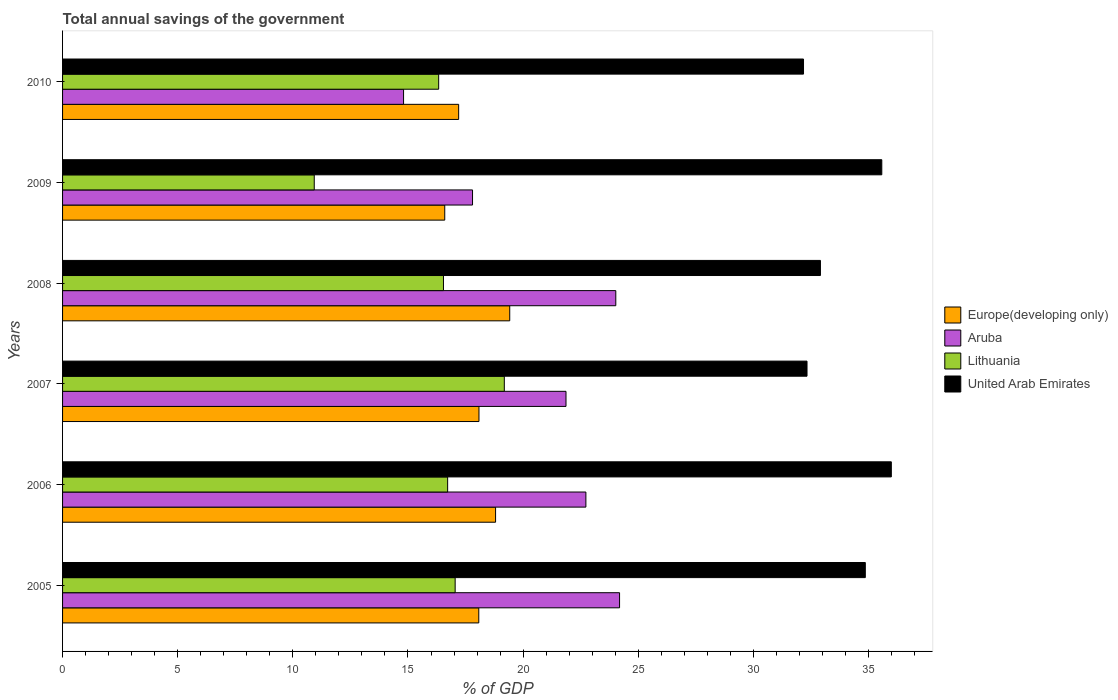How many bars are there on the 2nd tick from the top?
Give a very brief answer. 4. How many bars are there on the 6th tick from the bottom?
Offer a terse response. 4. What is the label of the 1st group of bars from the top?
Your response must be concise. 2010. What is the total annual savings of the government in Europe(developing only) in 2006?
Your response must be concise. 18.8. Across all years, what is the maximum total annual savings of the government in Europe(developing only)?
Give a very brief answer. 19.42. Across all years, what is the minimum total annual savings of the government in Aruba?
Give a very brief answer. 14.81. In which year was the total annual savings of the government in Aruba maximum?
Give a very brief answer. 2005. What is the total total annual savings of the government in Europe(developing only) in the graph?
Make the answer very short. 108.18. What is the difference between the total annual savings of the government in Europe(developing only) in 2005 and that in 2008?
Make the answer very short. -1.34. What is the difference between the total annual savings of the government in Lithuania in 2010 and the total annual savings of the government in United Arab Emirates in 2005?
Provide a succinct answer. -18.53. What is the average total annual savings of the government in Europe(developing only) per year?
Offer a terse response. 18.03. In the year 2009, what is the difference between the total annual savings of the government in United Arab Emirates and total annual savings of the government in Europe(developing only)?
Offer a very short reply. 18.98. What is the ratio of the total annual savings of the government in Europe(developing only) in 2005 to that in 2010?
Your answer should be very brief. 1.05. What is the difference between the highest and the second highest total annual savings of the government in Lithuania?
Keep it short and to the point. 2.14. What is the difference between the highest and the lowest total annual savings of the government in Aruba?
Make the answer very short. 9.38. In how many years, is the total annual savings of the government in United Arab Emirates greater than the average total annual savings of the government in United Arab Emirates taken over all years?
Provide a short and direct response. 3. Is it the case that in every year, the sum of the total annual savings of the government in United Arab Emirates and total annual savings of the government in Aruba is greater than the sum of total annual savings of the government in Lithuania and total annual savings of the government in Europe(developing only)?
Your answer should be compact. Yes. What does the 1st bar from the top in 2010 represents?
Offer a terse response. United Arab Emirates. What does the 4th bar from the bottom in 2007 represents?
Your answer should be very brief. United Arab Emirates. Is it the case that in every year, the sum of the total annual savings of the government in Europe(developing only) and total annual savings of the government in United Arab Emirates is greater than the total annual savings of the government in Aruba?
Provide a succinct answer. Yes. Are all the bars in the graph horizontal?
Provide a succinct answer. Yes. Does the graph contain any zero values?
Your response must be concise. No. Does the graph contain grids?
Give a very brief answer. No. What is the title of the graph?
Ensure brevity in your answer.  Total annual savings of the government. Does "Tonga" appear as one of the legend labels in the graph?
Ensure brevity in your answer.  No. What is the label or title of the X-axis?
Offer a very short reply. % of GDP. What is the label or title of the Y-axis?
Provide a short and direct response. Years. What is the % of GDP in Europe(developing only) in 2005?
Make the answer very short. 18.07. What is the % of GDP in Aruba in 2005?
Offer a very short reply. 24.19. What is the % of GDP in Lithuania in 2005?
Make the answer very short. 17.05. What is the % of GDP in United Arab Emirates in 2005?
Your response must be concise. 34.86. What is the % of GDP of Europe(developing only) in 2006?
Make the answer very short. 18.8. What is the % of GDP in Aruba in 2006?
Provide a short and direct response. 22.73. What is the % of GDP in Lithuania in 2006?
Ensure brevity in your answer.  16.72. What is the % of GDP of United Arab Emirates in 2006?
Your answer should be compact. 35.99. What is the % of GDP in Europe(developing only) in 2007?
Make the answer very short. 18.08. What is the % of GDP in Aruba in 2007?
Offer a terse response. 21.86. What is the % of GDP of Lithuania in 2007?
Make the answer very short. 19.18. What is the % of GDP in United Arab Emirates in 2007?
Offer a very short reply. 32.33. What is the % of GDP in Europe(developing only) in 2008?
Provide a short and direct response. 19.42. What is the % of GDP in Aruba in 2008?
Make the answer very short. 24.02. What is the % of GDP of Lithuania in 2008?
Offer a terse response. 16.54. What is the % of GDP in United Arab Emirates in 2008?
Give a very brief answer. 32.91. What is the % of GDP in Europe(developing only) in 2009?
Your response must be concise. 16.6. What is the % of GDP in Aruba in 2009?
Offer a very short reply. 17.8. What is the % of GDP of Lithuania in 2009?
Ensure brevity in your answer.  10.93. What is the % of GDP of United Arab Emirates in 2009?
Offer a terse response. 35.58. What is the % of GDP of Europe(developing only) in 2010?
Your answer should be compact. 17.2. What is the % of GDP in Aruba in 2010?
Your answer should be compact. 14.81. What is the % of GDP of Lithuania in 2010?
Provide a succinct answer. 16.33. What is the % of GDP of United Arab Emirates in 2010?
Offer a terse response. 32.18. Across all years, what is the maximum % of GDP in Europe(developing only)?
Your answer should be very brief. 19.42. Across all years, what is the maximum % of GDP in Aruba?
Offer a terse response. 24.19. Across all years, what is the maximum % of GDP in Lithuania?
Your response must be concise. 19.18. Across all years, what is the maximum % of GDP of United Arab Emirates?
Offer a very short reply. 35.99. Across all years, what is the minimum % of GDP of Europe(developing only)?
Provide a short and direct response. 16.6. Across all years, what is the minimum % of GDP in Aruba?
Your response must be concise. 14.81. Across all years, what is the minimum % of GDP of Lithuania?
Make the answer very short. 10.93. Across all years, what is the minimum % of GDP in United Arab Emirates?
Provide a short and direct response. 32.18. What is the total % of GDP in Europe(developing only) in the graph?
Provide a short and direct response. 108.18. What is the total % of GDP in Aruba in the graph?
Offer a very short reply. 125.41. What is the total % of GDP in Lithuania in the graph?
Make the answer very short. 96.76. What is the total % of GDP of United Arab Emirates in the graph?
Your answer should be very brief. 203.84. What is the difference between the % of GDP in Europe(developing only) in 2005 and that in 2006?
Provide a succinct answer. -0.73. What is the difference between the % of GDP in Aruba in 2005 and that in 2006?
Provide a succinct answer. 1.46. What is the difference between the % of GDP in Lithuania in 2005 and that in 2006?
Give a very brief answer. 0.33. What is the difference between the % of GDP of United Arab Emirates in 2005 and that in 2006?
Provide a short and direct response. -1.13. What is the difference between the % of GDP of Europe(developing only) in 2005 and that in 2007?
Keep it short and to the point. -0.01. What is the difference between the % of GDP in Aruba in 2005 and that in 2007?
Keep it short and to the point. 2.33. What is the difference between the % of GDP of Lithuania in 2005 and that in 2007?
Your answer should be compact. -2.13. What is the difference between the % of GDP of United Arab Emirates in 2005 and that in 2007?
Ensure brevity in your answer.  2.53. What is the difference between the % of GDP in Europe(developing only) in 2005 and that in 2008?
Provide a succinct answer. -1.34. What is the difference between the % of GDP in Aruba in 2005 and that in 2008?
Your answer should be compact. 0.16. What is the difference between the % of GDP of Lithuania in 2005 and that in 2008?
Provide a succinct answer. 0.51. What is the difference between the % of GDP in United Arab Emirates in 2005 and that in 2008?
Make the answer very short. 1.95. What is the difference between the % of GDP in Europe(developing only) in 2005 and that in 2009?
Ensure brevity in your answer.  1.48. What is the difference between the % of GDP in Aruba in 2005 and that in 2009?
Offer a very short reply. 6.39. What is the difference between the % of GDP in Lithuania in 2005 and that in 2009?
Provide a short and direct response. 6.12. What is the difference between the % of GDP in United Arab Emirates in 2005 and that in 2009?
Give a very brief answer. -0.72. What is the difference between the % of GDP in Europe(developing only) in 2005 and that in 2010?
Offer a very short reply. 0.87. What is the difference between the % of GDP in Aruba in 2005 and that in 2010?
Offer a very short reply. 9.38. What is the difference between the % of GDP in Lithuania in 2005 and that in 2010?
Keep it short and to the point. 0.72. What is the difference between the % of GDP in United Arab Emirates in 2005 and that in 2010?
Offer a terse response. 2.68. What is the difference between the % of GDP of Europe(developing only) in 2006 and that in 2007?
Provide a short and direct response. 0.72. What is the difference between the % of GDP in Aruba in 2006 and that in 2007?
Make the answer very short. 0.86. What is the difference between the % of GDP of Lithuania in 2006 and that in 2007?
Offer a very short reply. -2.46. What is the difference between the % of GDP in United Arab Emirates in 2006 and that in 2007?
Provide a succinct answer. 3.66. What is the difference between the % of GDP in Europe(developing only) in 2006 and that in 2008?
Provide a succinct answer. -0.61. What is the difference between the % of GDP of Aruba in 2006 and that in 2008?
Keep it short and to the point. -1.3. What is the difference between the % of GDP of Lithuania in 2006 and that in 2008?
Provide a short and direct response. 0.18. What is the difference between the % of GDP of United Arab Emirates in 2006 and that in 2008?
Provide a short and direct response. 3.08. What is the difference between the % of GDP of Europe(developing only) in 2006 and that in 2009?
Provide a succinct answer. 2.21. What is the difference between the % of GDP of Aruba in 2006 and that in 2009?
Offer a terse response. 4.92. What is the difference between the % of GDP of Lithuania in 2006 and that in 2009?
Provide a short and direct response. 5.79. What is the difference between the % of GDP in United Arab Emirates in 2006 and that in 2009?
Ensure brevity in your answer.  0.41. What is the difference between the % of GDP in Europe(developing only) in 2006 and that in 2010?
Make the answer very short. 1.6. What is the difference between the % of GDP of Aruba in 2006 and that in 2010?
Your answer should be compact. 7.92. What is the difference between the % of GDP in Lithuania in 2006 and that in 2010?
Offer a terse response. 0.39. What is the difference between the % of GDP of United Arab Emirates in 2006 and that in 2010?
Offer a terse response. 3.81. What is the difference between the % of GDP in Europe(developing only) in 2007 and that in 2008?
Give a very brief answer. -1.34. What is the difference between the % of GDP in Aruba in 2007 and that in 2008?
Offer a terse response. -2.16. What is the difference between the % of GDP in Lithuania in 2007 and that in 2008?
Offer a very short reply. 2.64. What is the difference between the % of GDP in United Arab Emirates in 2007 and that in 2008?
Your response must be concise. -0.58. What is the difference between the % of GDP in Europe(developing only) in 2007 and that in 2009?
Your answer should be compact. 1.49. What is the difference between the % of GDP in Aruba in 2007 and that in 2009?
Your answer should be very brief. 4.06. What is the difference between the % of GDP of Lithuania in 2007 and that in 2009?
Keep it short and to the point. 8.25. What is the difference between the % of GDP in United Arab Emirates in 2007 and that in 2009?
Your response must be concise. -3.25. What is the difference between the % of GDP of Europe(developing only) in 2007 and that in 2010?
Your answer should be very brief. 0.88. What is the difference between the % of GDP of Aruba in 2007 and that in 2010?
Offer a very short reply. 7.05. What is the difference between the % of GDP of Lithuania in 2007 and that in 2010?
Ensure brevity in your answer.  2.85. What is the difference between the % of GDP in United Arab Emirates in 2007 and that in 2010?
Keep it short and to the point. 0.15. What is the difference between the % of GDP of Europe(developing only) in 2008 and that in 2009?
Offer a very short reply. 2.82. What is the difference between the % of GDP of Aruba in 2008 and that in 2009?
Give a very brief answer. 6.22. What is the difference between the % of GDP of Lithuania in 2008 and that in 2009?
Offer a terse response. 5.61. What is the difference between the % of GDP of United Arab Emirates in 2008 and that in 2009?
Keep it short and to the point. -2.66. What is the difference between the % of GDP in Europe(developing only) in 2008 and that in 2010?
Your answer should be very brief. 2.22. What is the difference between the % of GDP in Aruba in 2008 and that in 2010?
Ensure brevity in your answer.  9.22. What is the difference between the % of GDP of Lithuania in 2008 and that in 2010?
Make the answer very short. 0.21. What is the difference between the % of GDP in United Arab Emirates in 2008 and that in 2010?
Offer a terse response. 0.73. What is the difference between the % of GDP in Europe(developing only) in 2009 and that in 2010?
Offer a terse response. -0.6. What is the difference between the % of GDP of Aruba in 2009 and that in 2010?
Make the answer very short. 3. What is the difference between the % of GDP of Lithuania in 2009 and that in 2010?
Ensure brevity in your answer.  -5.4. What is the difference between the % of GDP in United Arab Emirates in 2009 and that in 2010?
Offer a very short reply. 3.4. What is the difference between the % of GDP of Europe(developing only) in 2005 and the % of GDP of Aruba in 2006?
Your answer should be compact. -4.65. What is the difference between the % of GDP of Europe(developing only) in 2005 and the % of GDP of Lithuania in 2006?
Ensure brevity in your answer.  1.35. What is the difference between the % of GDP in Europe(developing only) in 2005 and the % of GDP in United Arab Emirates in 2006?
Your response must be concise. -17.92. What is the difference between the % of GDP in Aruba in 2005 and the % of GDP in Lithuania in 2006?
Give a very brief answer. 7.47. What is the difference between the % of GDP in Aruba in 2005 and the % of GDP in United Arab Emirates in 2006?
Provide a succinct answer. -11.8. What is the difference between the % of GDP of Lithuania in 2005 and the % of GDP of United Arab Emirates in 2006?
Provide a short and direct response. -18.94. What is the difference between the % of GDP in Europe(developing only) in 2005 and the % of GDP in Aruba in 2007?
Offer a very short reply. -3.79. What is the difference between the % of GDP in Europe(developing only) in 2005 and the % of GDP in Lithuania in 2007?
Your answer should be compact. -1.11. What is the difference between the % of GDP of Europe(developing only) in 2005 and the % of GDP of United Arab Emirates in 2007?
Make the answer very short. -14.25. What is the difference between the % of GDP of Aruba in 2005 and the % of GDP of Lithuania in 2007?
Your answer should be very brief. 5. What is the difference between the % of GDP in Aruba in 2005 and the % of GDP in United Arab Emirates in 2007?
Your response must be concise. -8.14. What is the difference between the % of GDP in Lithuania in 2005 and the % of GDP in United Arab Emirates in 2007?
Offer a terse response. -15.28. What is the difference between the % of GDP in Europe(developing only) in 2005 and the % of GDP in Aruba in 2008?
Provide a succinct answer. -5.95. What is the difference between the % of GDP in Europe(developing only) in 2005 and the % of GDP in Lithuania in 2008?
Make the answer very short. 1.53. What is the difference between the % of GDP of Europe(developing only) in 2005 and the % of GDP of United Arab Emirates in 2008?
Give a very brief answer. -14.84. What is the difference between the % of GDP in Aruba in 2005 and the % of GDP in Lithuania in 2008?
Your answer should be very brief. 7.65. What is the difference between the % of GDP in Aruba in 2005 and the % of GDP in United Arab Emirates in 2008?
Give a very brief answer. -8.72. What is the difference between the % of GDP of Lithuania in 2005 and the % of GDP of United Arab Emirates in 2008?
Provide a succinct answer. -15.86. What is the difference between the % of GDP of Europe(developing only) in 2005 and the % of GDP of Aruba in 2009?
Your response must be concise. 0.27. What is the difference between the % of GDP of Europe(developing only) in 2005 and the % of GDP of Lithuania in 2009?
Offer a terse response. 7.14. What is the difference between the % of GDP of Europe(developing only) in 2005 and the % of GDP of United Arab Emirates in 2009?
Give a very brief answer. -17.5. What is the difference between the % of GDP in Aruba in 2005 and the % of GDP in Lithuania in 2009?
Provide a short and direct response. 13.26. What is the difference between the % of GDP of Aruba in 2005 and the % of GDP of United Arab Emirates in 2009?
Offer a very short reply. -11.39. What is the difference between the % of GDP of Lithuania in 2005 and the % of GDP of United Arab Emirates in 2009?
Offer a very short reply. -18.53. What is the difference between the % of GDP of Europe(developing only) in 2005 and the % of GDP of Aruba in 2010?
Keep it short and to the point. 3.27. What is the difference between the % of GDP in Europe(developing only) in 2005 and the % of GDP in Lithuania in 2010?
Your answer should be very brief. 1.74. What is the difference between the % of GDP of Europe(developing only) in 2005 and the % of GDP of United Arab Emirates in 2010?
Offer a terse response. -14.1. What is the difference between the % of GDP in Aruba in 2005 and the % of GDP in Lithuania in 2010?
Give a very brief answer. 7.86. What is the difference between the % of GDP in Aruba in 2005 and the % of GDP in United Arab Emirates in 2010?
Your answer should be compact. -7.99. What is the difference between the % of GDP in Lithuania in 2005 and the % of GDP in United Arab Emirates in 2010?
Keep it short and to the point. -15.13. What is the difference between the % of GDP in Europe(developing only) in 2006 and the % of GDP in Aruba in 2007?
Offer a terse response. -3.06. What is the difference between the % of GDP in Europe(developing only) in 2006 and the % of GDP in Lithuania in 2007?
Keep it short and to the point. -0.38. What is the difference between the % of GDP in Europe(developing only) in 2006 and the % of GDP in United Arab Emirates in 2007?
Provide a short and direct response. -13.52. What is the difference between the % of GDP of Aruba in 2006 and the % of GDP of Lithuania in 2007?
Keep it short and to the point. 3.54. What is the difference between the % of GDP of Aruba in 2006 and the % of GDP of United Arab Emirates in 2007?
Your answer should be very brief. -9.6. What is the difference between the % of GDP in Lithuania in 2006 and the % of GDP in United Arab Emirates in 2007?
Offer a terse response. -15.61. What is the difference between the % of GDP of Europe(developing only) in 2006 and the % of GDP of Aruba in 2008?
Give a very brief answer. -5.22. What is the difference between the % of GDP in Europe(developing only) in 2006 and the % of GDP in Lithuania in 2008?
Keep it short and to the point. 2.26. What is the difference between the % of GDP in Europe(developing only) in 2006 and the % of GDP in United Arab Emirates in 2008?
Your response must be concise. -14.11. What is the difference between the % of GDP in Aruba in 2006 and the % of GDP in Lithuania in 2008?
Your answer should be compact. 6.18. What is the difference between the % of GDP of Aruba in 2006 and the % of GDP of United Arab Emirates in 2008?
Ensure brevity in your answer.  -10.19. What is the difference between the % of GDP of Lithuania in 2006 and the % of GDP of United Arab Emirates in 2008?
Make the answer very short. -16.19. What is the difference between the % of GDP of Europe(developing only) in 2006 and the % of GDP of Lithuania in 2009?
Give a very brief answer. 7.87. What is the difference between the % of GDP of Europe(developing only) in 2006 and the % of GDP of United Arab Emirates in 2009?
Make the answer very short. -16.77. What is the difference between the % of GDP of Aruba in 2006 and the % of GDP of Lithuania in 2009?
Your answer should be very brief. 11.8. What is the difference between the % of GDP of Aruba in 2006 and the % of GDP of United Arab Emirates in 2009?
Give a very brief answer. -12.85. What is the difference between the % of GDP in Lithuania in 2006 and the % of GDP in United Arab Emirates in 2009?
Your response must be concise. -18.85. What is the difference between the % of GDP of Europe(developing only) in 2006 and the % of GDP of Aruba in 2010?
Your answer should be very brief. 4. What is the difference between the % of GDP of Europe(developing only) in 2006 and the % of GDP of Lithuania in 2010?
Give a very brief answer. 2.47. What is the difference between the % of GDP in Europe(developing only) in 2006 and the % of GDP in United Arab Emirates in 2010?
Provide a short and direct response. -13.37. What is the difference between the % of GDP of Aruba in 2006 and the % of GDP of Lithuania in 2010?
Keep it short and to the point. 6.39. What is the difference between the % of GDP in Aruba in 2006 and the % of GDP in United Arab Emirates in 2010?
Provide a short and direct response. -9.45. What is the difference between the % of GDP of Lithuania in 2006 and the % of GDP of United Arab Emirates in 2010?
Keep it short and to the point. -15.45. What is the difference between the % of GDP in Europe(developing only) in 2007 and the % of GDP in Aruba in 2008?
Your answer should be very brief. -5.94. What is the difference between the % of GDP in Europe(developing only) in 2007 and the % of GDP in Lithuania in 2008?
Ensure brevity in your answer.  1.54. What is the difference between the % of GDP in Europe(developing only) in 2007 and the % of GDP in United Arab Emirates in 2008?
Keep it short and to the point. -14.83. What is the difference between the % of GDP in Aruba in 2007 and the % of GDP in Lithuania in 2008?
Make the answer very short. 5.32. What is the difference between the % of GDP in Aruba in 2007 and the % of GDP in United Arab Emirates in 2008?
Offer a terse response. -11.05. What is the difference between the % of GDP in Lithuania in 2007 and the % of GDP in United Arab Emirates in 2008?
Provide a short and direct response. -13.73. What is the difference between the % of GDP in Europe(developing only) in 2007 and the % of GDP in Aruba in 2009?
Provide a succinct answer. 0.28. What is the difference between the % of GDP in Europe(developing only) in 2007 and the % of GDP in Lithuania in 2009?
Give a very brief answer. 7.15. What is the difference between the % of GDP in Europe(developing only) in 2007 and the % of GDP in United Arab Emirates in 2009?
Your answer should be very brief. -17.49. What is the difference between the % of GDP in Aruba in 2007 and the % of GDP in Lithuania in 2009?
Your answer should be very brief. 10.93. What is the difference between the % of GDP of Aruba in 2007 and the % of GDP of United Arab Emirates in 2009?
Make the answer very short. -13.71. What is the difference between the % of GDP of Lithuania in 2007 and the % of GDP of United Arab Emirates in 2009?
Provide a succinct answer. -16.39. What is the difference between the % of GDP of Europe(developing only) in 2007 and the % of GDP of Aruba in 2010?
Provide a succinct answer. 3.27. What is the difference between the % of GDP of Europe(developing only) in 2007 and the % of GDP of Lithuania in 2010?
Your answer should be very brief. 1.75. What is the difference between the % of GDP of Europe(developing only) in 2007 and the % of GDP of United Arab Emirates in 2010?
Offer a terse response. -14.09. What is the difference between the % of GDP in Aruba in 2007 and the % of GDP in Lithuania in 2010?
Make the answer very short. 5.53. What is the difference between the % of GDP of Aruba in 2007 and the % of GDP of United Arab Emirates in 2010?
Offer a terse response. -10.31. What is the difference between the % of GDP in Lithuania in 2007 and the % of GDP in United Arab Emirates in 2010?
Offer a very short reply. -12.99. What is the difference between the % of GDP of Europe(developing only) in 2008 and the % of GDP of Aruba in 2009?
Keep it short and to the point. 1.62. What is the difference between the % of GDP of Europe(developing only) in 2008 and the % of GDP of Lithuania in 2009?
Provide a succinct answer. 8.49. What is the difference between the % of GDP of Europe(developing only) in 2008 and the % of GDP of United Arab Emirates in 2009?
Ensure brevity in your answer.  -16.16. What is the difference between the % of GDP in Aruba in 2008 and the % of GDP in Lithuania in 2009?
Your answer should be compact. 13.09. What is the difference between the % of GDP in Aruba in 2008 and the % of GDP in United Arab Emirates in 2009?
Offer a terse response. -11.55. What is the difference between the % of GDP in Lithuania in 2008 and the % of GDP in United Arab Emirates in 2009?
Keep it short and to the point. -19.03. What is the difference between the % of GDP of Europe(developing only) in 2008 and the % of GDP of Aruba in 2010?
Keep it short and to the point. 4.61. What is the difference between the % of GDP in Europe(developing only) in 2008 and the % of GDP in Lithuania in 2010?
Ensure brevity in your answer.  3.09. What is the difference between the % of GDP in Europe(developing only) in 2008 and the % of GDP in United Arab Emirates in 2010?
Your response must be concise. -12.76. What is the difference between the % of GDP of Aruba in 2008 and the % of GDP of Lithuania in 2010?
Ensure brevity in your answer.  7.69. What is the difference between the % of GDP in Aruba in 2008 and the % of GDP in United Arab Emirates in 2010?
Your response must be concise. -8.15. What is the difference between the % of GDP in Lithuania in 2008 and the % of GDP in United Arab Emirates in 2010?
Give a very brief answer. -15.64. What is the difference between the % of GDP of Europe(developing only) in 2009 and the % of GDP of Aruba in 2010?
Your response must be concise. 1.79. What is the difference between the % of GDP in Europe(developing only) in 2009 and the % of GDP in Lithuania in 2010?
Ensure brevity in your answer.  0.26. What is the difference between the % of GDP of Europe(developing only) in 2009 and the % of GDP of United Arab Emirates in 2010?
Provide a short and direct response. -15.58. What is the difference between the % of GDP in Aruba in 2009 and the % of GDP in Lithuania in 2010?
Your answer should be very brief. 1.47. What is the difference between the % of GDP in Aruba in 2009 and the % of GDP in United Arab Emirates in 2010?
Offer a terse response. -14.37. What is the difference between the % of GDP in Lithuania in 2009 and the % of GDP in United Arab Emirates in 2010?
Provide a short and direct response. -21.25. What is the average % of GDP of Europe(developing only) per year?
Provide a succinct answer. 18.03. What is the average % of GDP in Aruba per year?
Offer a very short reply. 20.9. What is the average % of GDP of Lithuania per year?
Offer a terse response. 16.13. What is the average % of GDP in United Arab Emirates per year?
Provide a succinct answer. 33.97. In the year 2005, what is the difference between the % of GDP in Europe(developing only) and % of GDP in Aruba?
Provide a short and direct response. -6.11. In the year 2005, what is the difference between the % of GDP of Europe(developing only) and % of GDP of Lithuania?
Make the answer very short. 1.03. In the year 2005, what is the difference between the % of GDP in Europe(developing only) and % of GDP in United Arab Emirates?
Your answer should be compact. -16.79. In the year 2005, what is the difference between the % of GDP in Aruba and % of GDP in Lithuania?
Keep it short and to the point. 7.14. In the year 2005, what is the difference between the % of GDP of Aruba and % of GDP of United Arab Emirates?
Your response must be concise. -10.67. In the year 2005, what is the difference between the % of GDP in Lithuania and % of GDP in United Arab Emirates?
Offer a very short reply. -17.81. In the year 2006, what is the difference between the % of GDP in Europe(developing only) and % of GDP in Aruba?
Keep it short and to the point. -3.92. In the year 2006, what is the difference between the % of GDP in Europe(developing only) and % of GDP in Lithuania?
Offer a very short reply. 2.08. In the year 2006, what is the difference between the % of GDP of Europe(developing only) and % of GDP of United Arab Emirates?
Keep it short and to the point. -17.19. In the year 2006, what is the difference between the % of GDP in Aruba and % of GDP in Lithuania?
Your answer should be very brief. 6. In the year 2006, what is the difference between the % of GDP of Aruba and % of GDP of United Arab Emirates?
Keep it short and to the point. -13.26. In the year 2006, what is the difference between the % of GDP in Lithuania and % of GDP in United Arab Emirates?
Provide a short and direct response. -19.27. In the year 2007, what is the difference between the % of GDP of Europe(developing only) and % of GDP of Aruba?
Your answer should be very brief. -3.78. In the year 2007, what is the difference between the % of GDP in Europe(developing only) and % of GDP in Lithuania?
Provide a short and direct response. -1.1. In the year 2007, what is the difference between the % of GDP of Europe(developing only) and % of GDP of United Arab Emirates?
Provide a succinct answer. -14.25. In the year 2007, what is the difference between the % of GDP in Aruba and % of GDP in Lithuania?
Provide a short and direct response. 2.68. In the year 2007, what is the difference between the % of GDP of Aruba and % of GDP of United Arab Emirates?
Provide a succinct answer. -10.47. In the year 2007, what is the difference between the % of GDP of Lithuania and % of GDP of United Arab Emirates?
Offer a terse response. -13.14. In the year 2008, what is the difference between the % of GDP of Europe(developing only) and % of GDP of Aruba?
Give a very brief answer. -4.61. In the year 2008, what is the difference between the % of GDP in Europe(developing only) and % of GDP in Lithuania?
Your answer should be very brief. 2.88. In the year 2008, what is the difference between the % of GDP of Europe(developing only) and % of GDP of United Arab Emirates?
Keep it short and to the point. -13.49. In the year 2008, what is the difference between the % of GDP of Aruba and % of GDP of Lithuania?
Your answer should be very brief. 7.48. In the year 2008, what is the difference between the % of GDP in Aruba and % of GDP in United Arab Emirates?
Offer a very short reply. -8.89. In the year 2008, what is the difference between the % of GDP in Lithuania and % of GDP in United Arab Emirates?
Keep it short and to the point. -16.37. In the year 2009, what is the difference between the % of GDP in Europe(developing only) and % of GDP in Aruba?
Keep it short and to the point. -1.21. In the year 2009, what is the difference between the % of GDP of Europe(developing only) and % of GDP of Lithuania?
Ensure brevity in your answer.  5.67. In the year 2009, what is the difference between the % of GDP in Europe(developing only) and % of GDP in United Arab Emirates?
Provide a succinct answer. -18.98. In the year 2009, what is the difference between the % of GDP in Aruba and % of GDP in Lithuania?
Your answer should be very brief. 6.87. In the year 2009, what is the difference between the % of GDP of Aruba and % of GDP of United Arab Emirates?
Keep it short and to the point. -17.77. In the year 2009, what is the difference between the % of GDP of Lithuania and % of GDP of United Arab Emirates?
Your answer should be very brief. -24.65. In the year 2010, what is the difference between the % of GDP of Europe(developing only) and % of GDP of Aruba?
Your response must be concise. 2.39. In the year 2010, what is the difference between the % of GDP of Europe(developing only) and % of GDP of Lithuania?
Keep it short and to the point. 0.87. In the year 2010, what is the difference between the % of GDP in Europe(developing only) and % of GDP in United Arab Emirates?
Provide a short and direct response. -14.98. In the year 2010, what is the difference between the % of GDP of Aruba and % of GDP of Lithuania?
Provide a succinct answer. -1.52. In the year 2010, what is the difference between the % of GDP of Aruba and % of GDP of United Arab Emirates?
Provide a short and direct response. -17.37. In the year 2010, what is the difference between the % of GDP in Lithuania and % of GDP in United Arab Emirates?
Offer a terse response. -15.84. What is the ratio of the % of GDP of Europe(developing only) in 2005 to that in 2006?
Make the answer very short. 0.96. What is the ratio of the % of GDP in Aruba in 2005 to that in 2006?
Offer a very short reply. 1.06. What is the ratio of the % of GDP in Lithuania in 2005 to that in 2006?
Offer a terse response. 1.02. What is the ratio of the % of GDP in United Arab Emirates in 2005 to that in 2006?
Provide a short and direct response. 0.97. What is the ratio of the % of GDP of Aruba in 2005 to that in 2007?
Ensure brevity in your answer.  1.11. What is the ratio of the % of GDP in Lithuania in 2005 to that in 2007?
Offer a terse response. 0.89. What is the ratio of the % of GDP of United Arab Emirates in 2005 to that in 2007?
Your answer should be very brief. 1.08. What is the ratio of the % of GDP of Europe(developing only) in 2005 to that in 2008?
Offer a terse response. 0.93. What is the ratio of the % of GDP in Aruba in 2005 to that in 2008?
Your response must be concise. 1.01. What is the ratio of the % of GDP of Lithuania in 2005 to that in 2008?
Your answer should be very brief. 1.03. What is the ratio of the % of GDP of United Arab Emirates in 2005 to that in 2008?
Offer a terse response. 1.06. What is the ratio of the % of GDP of Europe(developing only) in 2005 to that in 2009?
Offer a terse response. 1.09. What is the ratio of the % of GDP of Aruba in 2005 to that in 2009?
Keep it short and to the point. 1.36. What is the ratio of the % of GDP of Lithuania in 2005 to that in 2009?
Give a very brief answer. 1.56. What is the ratio of the % of GDP of United Arab Emirates in 2005 to that in 2009?
Provide a succinct answer. 0.98. What is the ratio of the % of GDP of Europe(developing only) in 2005 to that in 2010?
Keep it short and to the point. 1.05. What is the ratio of the % of GDP in Aruba in 2005 to that in 2010?
Ensure brevity in your answer.  1.63. What is the ratio of the % of GDP in Lithuania in 2005 to that in 2010?
Your response must be concise. 1.04. What is the ratio of the % of GDP of United Arab Emirates in 2005 to that in 2010?
Offer a terse response. 1.08. What is the ratio of the % of GDP of Europe(developing only) in 2006 to that in 2007?
Offer a very short reply. 1.04. What is the ratio of the % of GDP of Aruba in 2006 to that in 2007?
Provide a succinct answer. 1.04. What is the ratio of the % of GDP of Lithuania in 2006 to that in 2007?
Give a very brief answer. 0.87. What is the ratio of the % of GDP in United Arab Emirates in 2006 to that in 2007?
Your response must be concise. 1.11. What is the ratio of the % of GDP in Europe(developing only) in 2006 to that in 2008?
Keep it short and to the point. 0.97. What is the ratio of the % of GDP in Aruba in 2006 to that in 2008?
Give a very brief answer. 0.95. What is the ratio of the % of GDP of Lithuania in 2006 to that in 2008?
Offer a very short reply. 1.01. What is the ratio of the % of GDP of United Arab Emirates in 2006 to that in 2008?
Keep it short and to the point. 1.09. What is the ratio of the % of GDP in Europe(developing only) in 2006 to that in 2009?
Give a very brief answer. 1.13. What is the ratio of the % of GDP in Aruba in 2006 to that in 2009?
Provide a succinct answer. 1.28. What is the ratio of the % of GDP in Lithuania in 2006 to that in 2009?
Make the answer very short. 1.53. What is the ratio of the % of GDP in United Arab Emirates in 2006 to that in 2009?
Your response must be concise. 1.01. What is the ratio of the % of GDP in Europe(developing only) in 2006 to that in 2010?
Your answer should be very brief. 1.09. What is the ratio of the % of GDP of Aruba in 2006 to that in 2010?
Keep it short and to the point. 1.53. What is the ratio of the % of GDP in Lithuania in 2006 to that in 2010?
Keep it short and to the point. 1.02. What is the ratio of the % of GDP in United Arab Emirates in 2006 to that in 2010?
Keep it short and to the point. 1.12. What is the ratio of the % of GDP in Europe(developing only) in 2007 to that in 2008?
Ensure brevity in your answer.  0.93. What is the ratio of the % of GDP of Aruba in 2007 to that in 2008?
Offer a terse response. 0.91. What is the ratio of the % of GDP in Lithuania in 2007 to that in 2008?
Your answer should be very brief. 1.16. What is the ratio of the % of GDP in United Arab Emirates in 2007 to that in 2008?
Your answer should be very brief. 0.98. What is the ratio of the % of GDP in Europe(developing only) in 2007 to that in 2009?
Your answer should be compact. 1.09. What is the ratio of the % of GDP of Aruba in 2007 to that in 2009?
Your answer should be very brief. 1.23. What is the ratio of the % of GDP of Lithuania in 2007 to that in 2009?
Offer a terse response. 1.76. What is the ratio of the % of GDP of United Arab Emirates in 2007 to that in 2009?
Your response must be concise. 0.91. What is the ratio of the % of GDP of Europe(developing only) in 2007 to that in 2010?
Your answer should be very brief. 1.05. What is the ratio of the % of GDP in Aruba in 2007 to that in 2010?
Your response must be concise. 1.48. What is the ratio of the % of GDP in Lithuania in 2007 to that in 2010?
Keep it short and to the point. 1.17. What is the ratio of the % of GDP in United Arab Emirates in 2007 to that in 2010?
Offer a terse response. 1. What is the ratio of the % of GDP of Europe(developing only) in 2008 to that in 2009?
Keep it short and to the point. 1.17. What is the ratio of the % of GDP in Aruba in 2008 to that in 2009?
Ensure brevity in your answer.  1.35. What is the ratio of the % of GDP of Lithuania in 2008 to that in 2009?
Offer a very short reply. 1.51. What is the ratio of the % of GDP in United Arab Emirates in 2008 to that in 2009?
Provide a succinct answer. 0.93. What is the ratio of the % of GDP in Europe(developing only) in 2008 to that in 2010?
Keep it short and to the point. 1.13. What is the ratio of the % of GDP in Aruba in 2008 to that in 2010?
Offer a very short reply. 1.62. What is the ratio of the % of GDP of Lithuania in 2008 to that in 2010?
Provide a short and direct response. 1.01. What is the ratio of the % of GDP in United Arab Emirates in 2008 to that in 2010?
Ensure brevity in your answer.  1.02. What is the ratio of the % of GDP of Europe(developing only) in 2009 to that in 2010?
Keep it short and to the point. 0.96. What is the ratio of the % of GDP in Aruba in 2009 to that in 2010?
Provide a short and direct response. 1.2. What is the ratio of the % of GDP in Lithuania in 2009 to that in 2010?
Your answer should be compact. 0.67. What is the ratio of the % of GDP of United Arab Emirates in 2009 to that in 2010?
Provide a succinct answer. 1.11. What is the difference between the highest and the second highest % of GDP in Europe(developing only)?
Provide a succinct answer. 0.61. What is the difference between the highest and the second highest % of GDP in Aruba?
Keep it short and to the point. 0.16. What is the difference between the highest and the second highest % of GDP of Lithuania?
Make the answer very short. 2.13. What is the difference between the highest and the second highest % of GDP of United Arab Emirates?
Provide a short and direct response. 0.41. What is the difference between the highest and the lowest % of GDP in Europe(developing only)?
Provide a short and direct response. 2.82. What is the difference between the highest and the lowest % of GDP of Aruba?
Provide a succinct answer. 9.38. What is the difference between the highest and the lowest % of GDP in Lithuania?
Provide a succinct answer. 8.25. What is the difference between the highest and the lowest % of GDP in United Arab Emirates?
Ensure brevity in your answer.  3.81. 